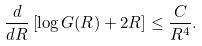Convert formula to latex. <formula><loc_0><loc_0><loc_500><loc_500>\frac { d } { d R } \left [ \log G ( R ) + 2 R \right ] \leq \frac { C } { R ^ { 4 } } .</formula> 